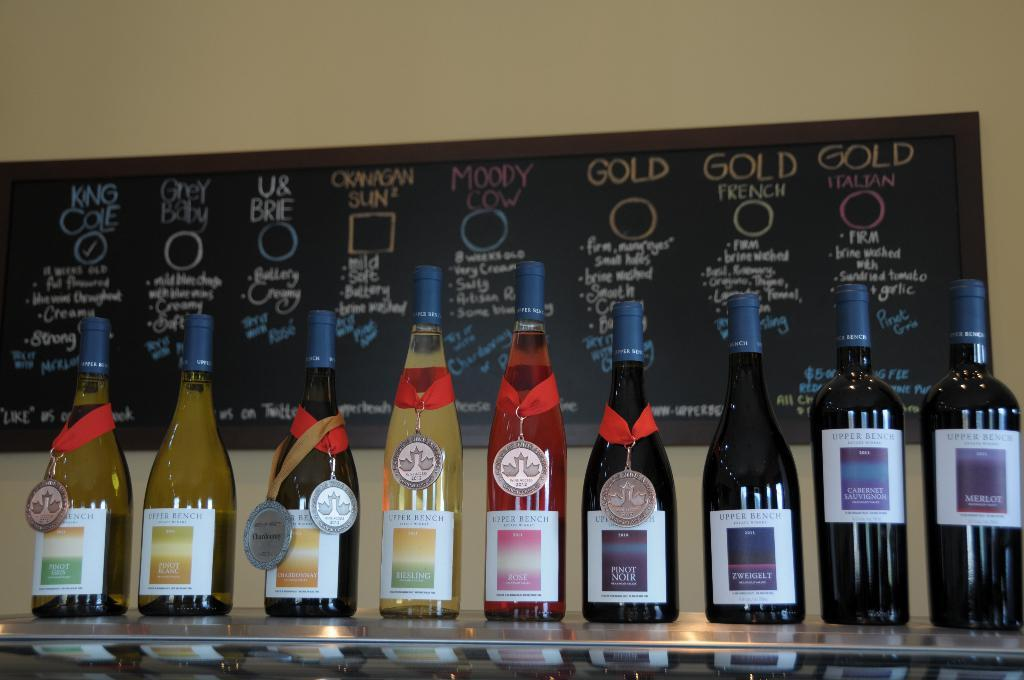<image>
Give a short and clear explanation of the subsequent image. A series of bottles are lined up in front of a board with King Cole checked. 